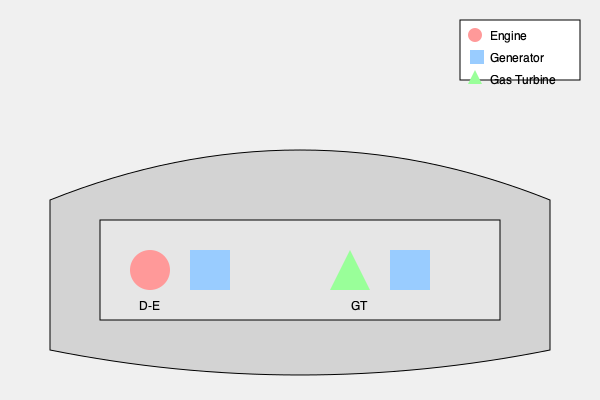Based on the engine room layout shown, which propulsion system is likely to provide faster acceleration and higher top speeds for the vessel, and why? To determine which propulsion system is likely to provide faster acceleration and higher top speeds, we need to analyze the components of each system:

1. Diesel-Electric (D-E) System:
   - Consists of a diesel engine (red circle) and an electric generator (blue square)
   - Diesel engines are known for their reliability and fuel efficiency
   - Electric propulsion allows for precise control and good low-speed maneuverability

2. Gas Turbine (GT) System:
   - Consists of a gas turbine (green triangle) and an electric generator (blue square)
   - Gas turbines have a higher power-to-weight ratio compared to diesel engines
   - They can produce more power in a smaller package

Comparing the two systems:

a) Power output: Gas turbines generally have a higher power output than diesel engines of similar size.

b) Weight: Gas turbine systems are typically lighter than diesel-electric systems, which can contribute to better overall vessel performance.

c) Acceleration: Gas turbines can reach full power more quickly than diesel engines, resulting in faster acceleration.

d) Top speed: Due to their higher power-to-weight ratio, gas turbine systems can often achieve higher top speeds.

e) Fuel consumption: Gas turbines usually consume more fuel than diesel engines, especially at lower speeds.

Given these factors, the gas turbine system is likely to provide faster acceleration and higher top speeds for the vessel. However, it's important to note that this comes at the cost of higher fuel consumption and potentially shorter range.
Answer: Gas Turbine system, due to higher power-to-weight ratio and faster power delivery. 